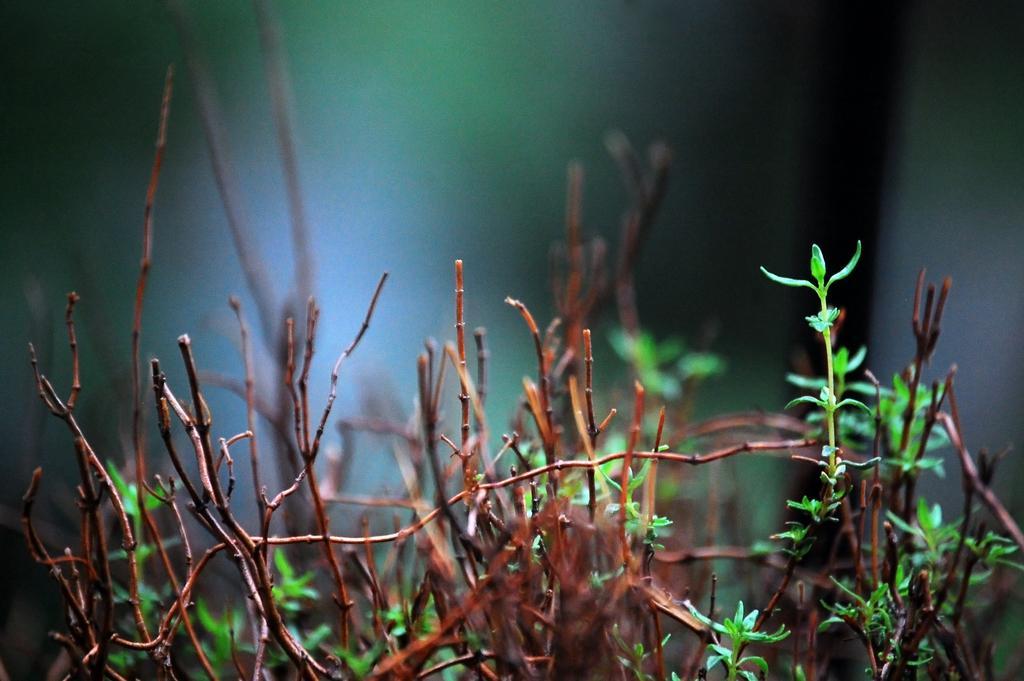How would you summarize this image in a sentence or two? In this image I can see few plants which are brown and green in color. I can see the blurry background. 